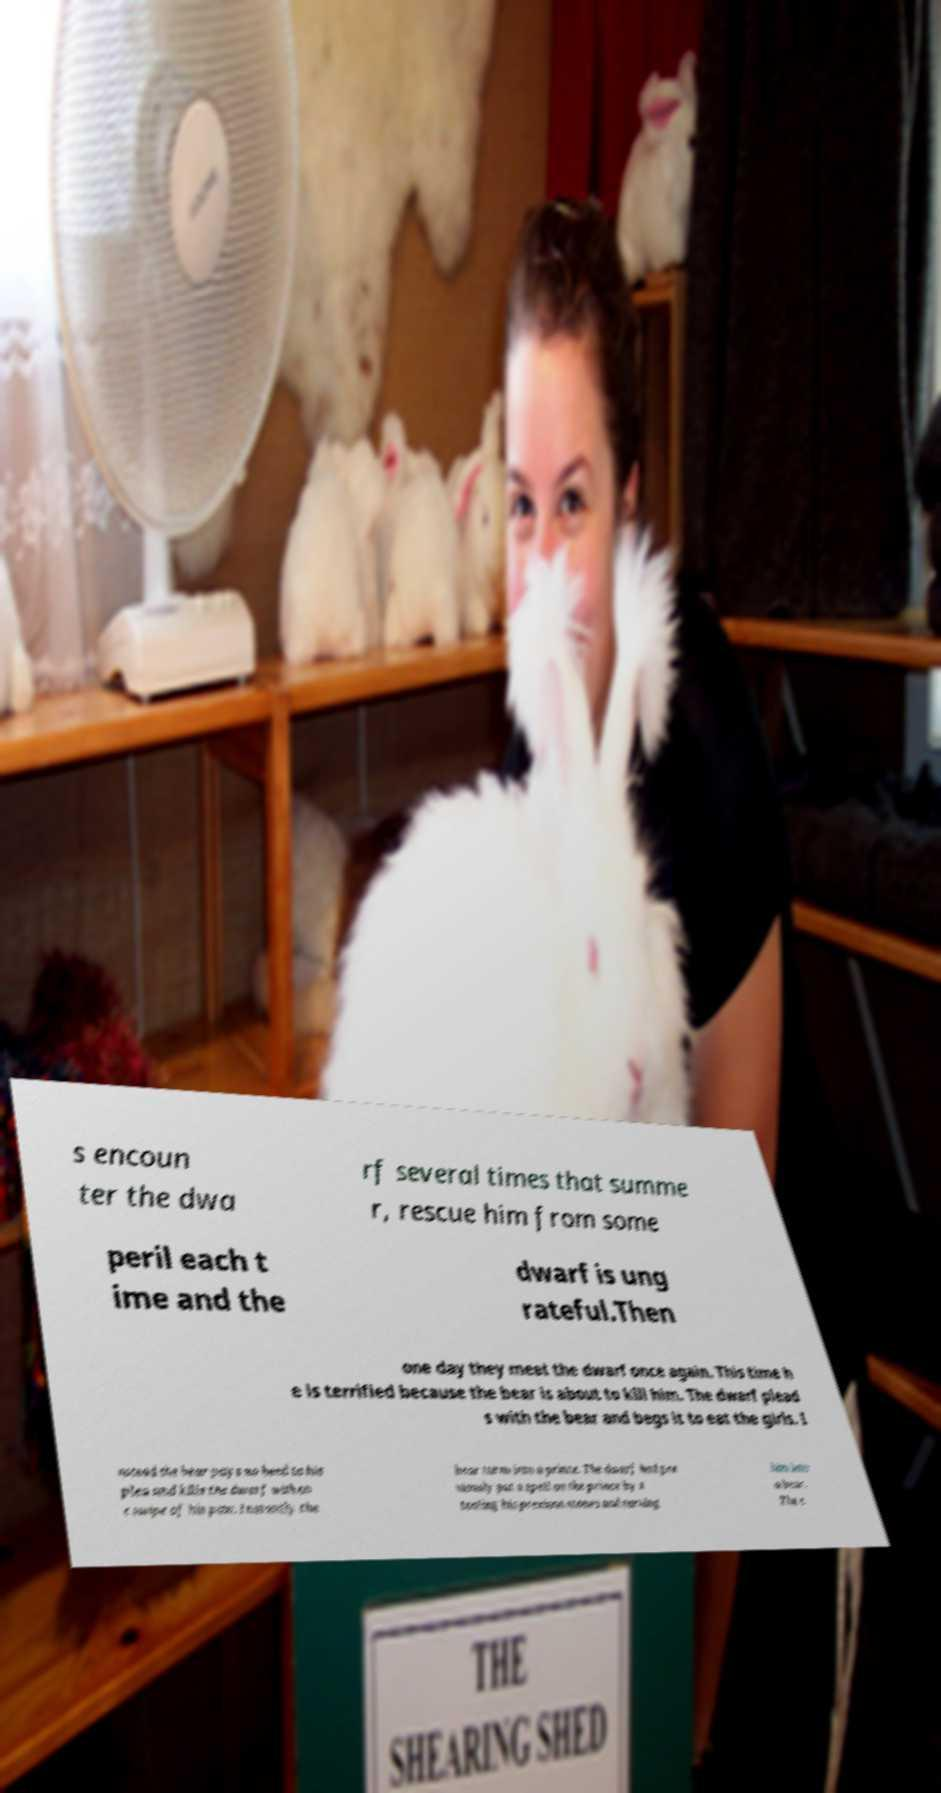What messages or text are displayed in this image? I need them in a readable, typed format. s encoun ter the dwa rf several times that summe r, rescue him from some peril each t ime and the dwarf is ung rateful.Then one day they meet the dwarf once again. This time h e is terrified because the bear is about to kill him. The dwarf plead s with the bear and begs it to eat the girls. I nstead the bear pays no heed to his plea and kills the dwarf with on e swipe of his paw. Instantly the bear turns into a prince. The dwarf had pre viously put a spell on the prince by s tealing his precious stones and turning him into a bear. The c 